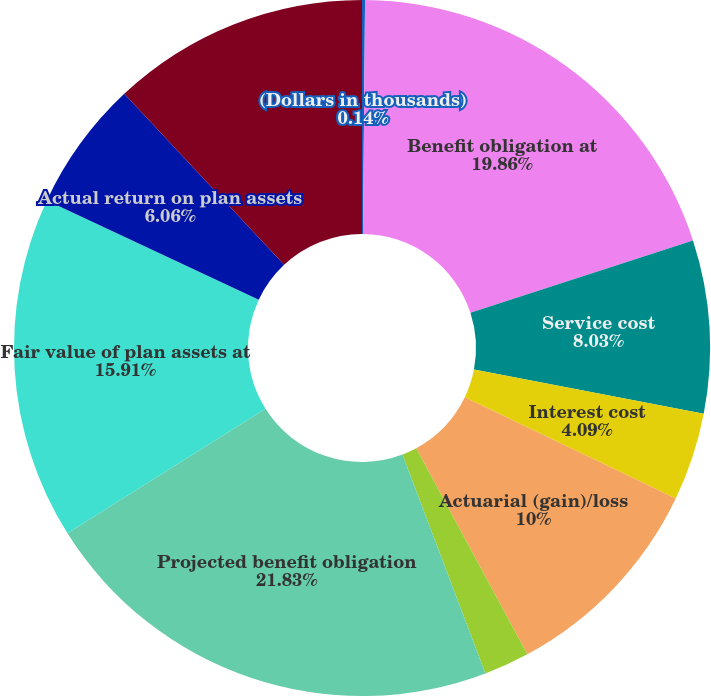<chart> <loc_0><loc_0><loc_500><loc_500><pie_chart><fcel>(Dollars in thousands)<fcel>Benefit obligation at<fcel>Service cost<fcel>Interest cost<fcel>Actuarial (gain)/loss<fcel>Benefits paid<fcel>Projected benefit obligation<fcel>Fair value of plan assets at<fcel>Actual return on plan assets<fcel>Actual contributions during<nl><fcel>0.14%<fcel>19.86%<fcel>8.03%<fcel>4.09%<fcel>10.0%<fcel>2.11%<fcel>21.83%<fcel>15.91%<fcel>6.06%<fcel>11.97%<nl></chart> 